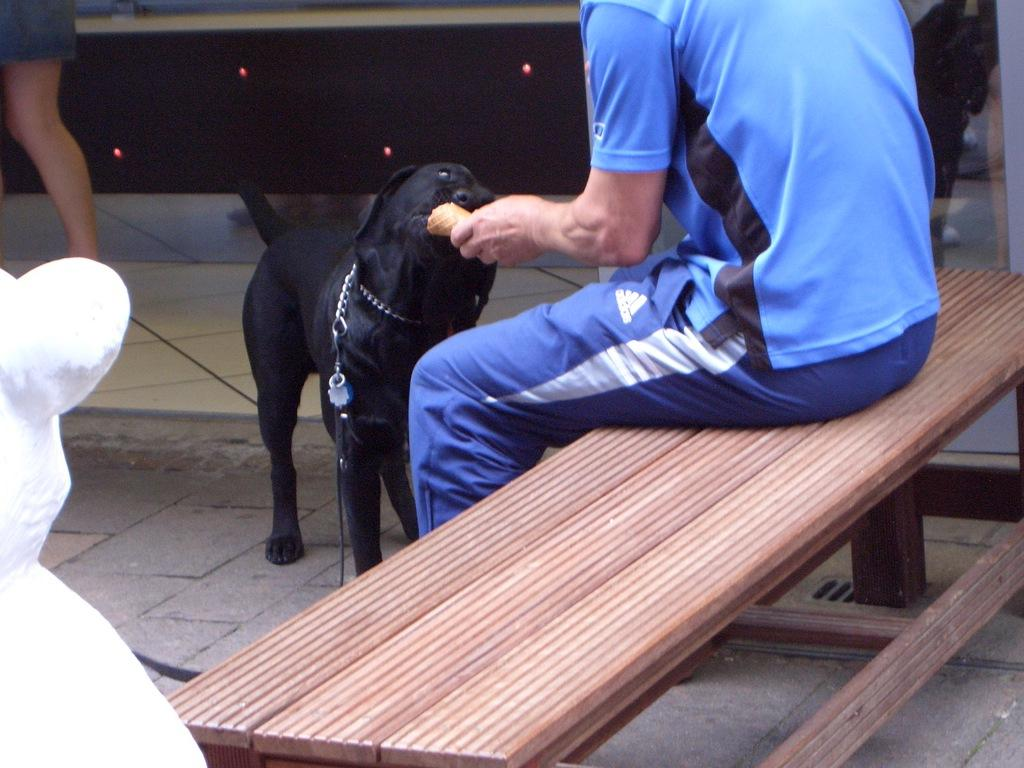What is the person in the image doing? There is a person sitting on a bench in the image. Can you describe any other object or living being in the image? There is a black color dog in front of the person. How many parcels are being carried by the brothers in the image? There are no brothers or parcels present in the image. What type of stick is the dog holding in its mouth in the image? There is no stick present in the image; the dog is not holding anything in its mouth. 